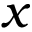Convert formula to latex. <formula><loc_0><loc_0><loc_500><loc_500>x</formula> 